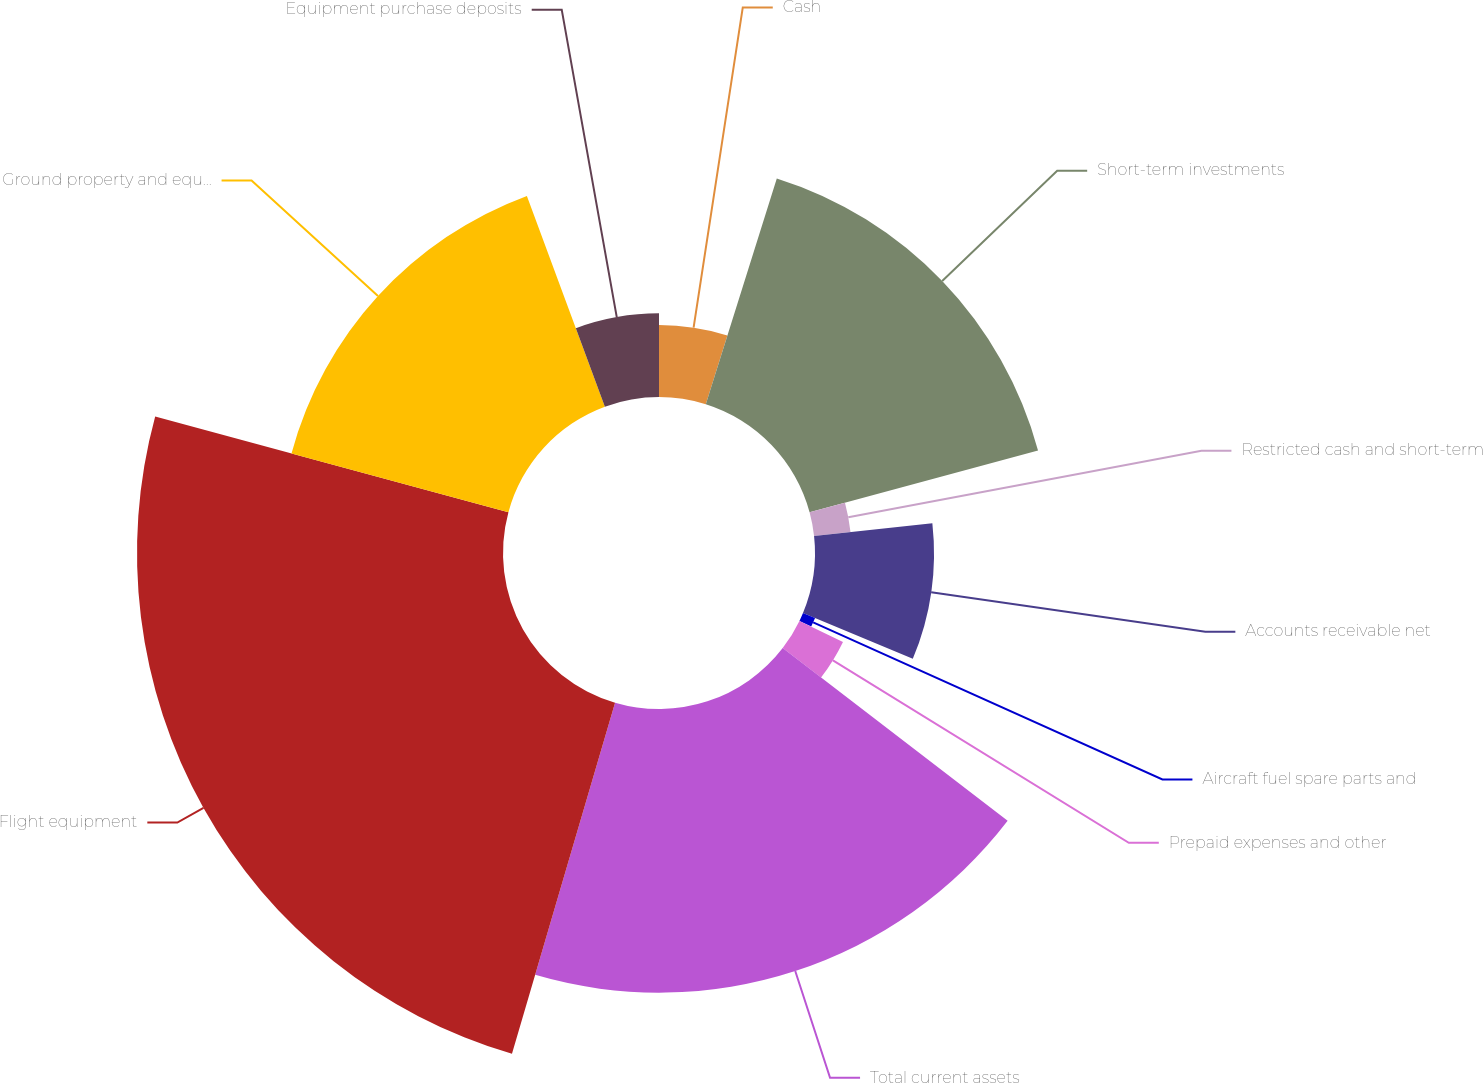Convert chart to OTSL. <chart><loc_0><loc_0><loc_500><loc_500><pie_chart><fcel>Cash<fcel>Short-term investments<fcel>Restricted cash and short-term<fcel>Accounts receivable net<fcel>Aircraft fuel spare parts and<fcel>Prepaid expenses and other<fcel>Total current assets<fcel>Flight equipment<fcel>Ground property and equipment<fcel>Equipment purchase deposits<nl><fcel>4.85%<fcel>15.95%<fcel>2.47%<fcel>8.02%<fcel>0.88%<fcel>3.26%<fcel>19.12%<fcel>24.67%<fcel>15.15%<fcel>5.64%<nl></chart> 